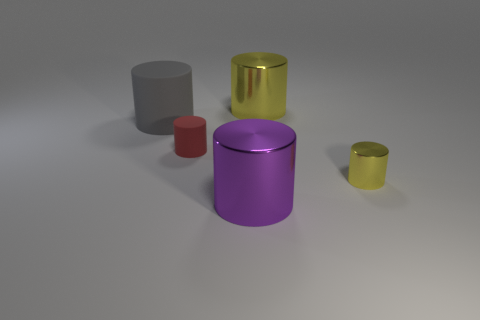Subtract 1 cylinders. How many cylinders are left? 4 Subtract all purple metallic cylinders. How many cylinders are left? 4 Subtract all blue cylinders. Subtract all purple balls. How many cylinders are left? 5 Add 1 big purple metallic things. How many objects exist? 6 Subtract 0 yellow blocks. How many objects are left? 5 Subtract all green balls. Subtract all gray rubber objects. How many objects are left? 4 Add 4 purple cylinders. How many purple cylinders are left? 5 Add 3 tiny yellow metal cylinders. How many tiny yellow metal cylinders exist? 4 